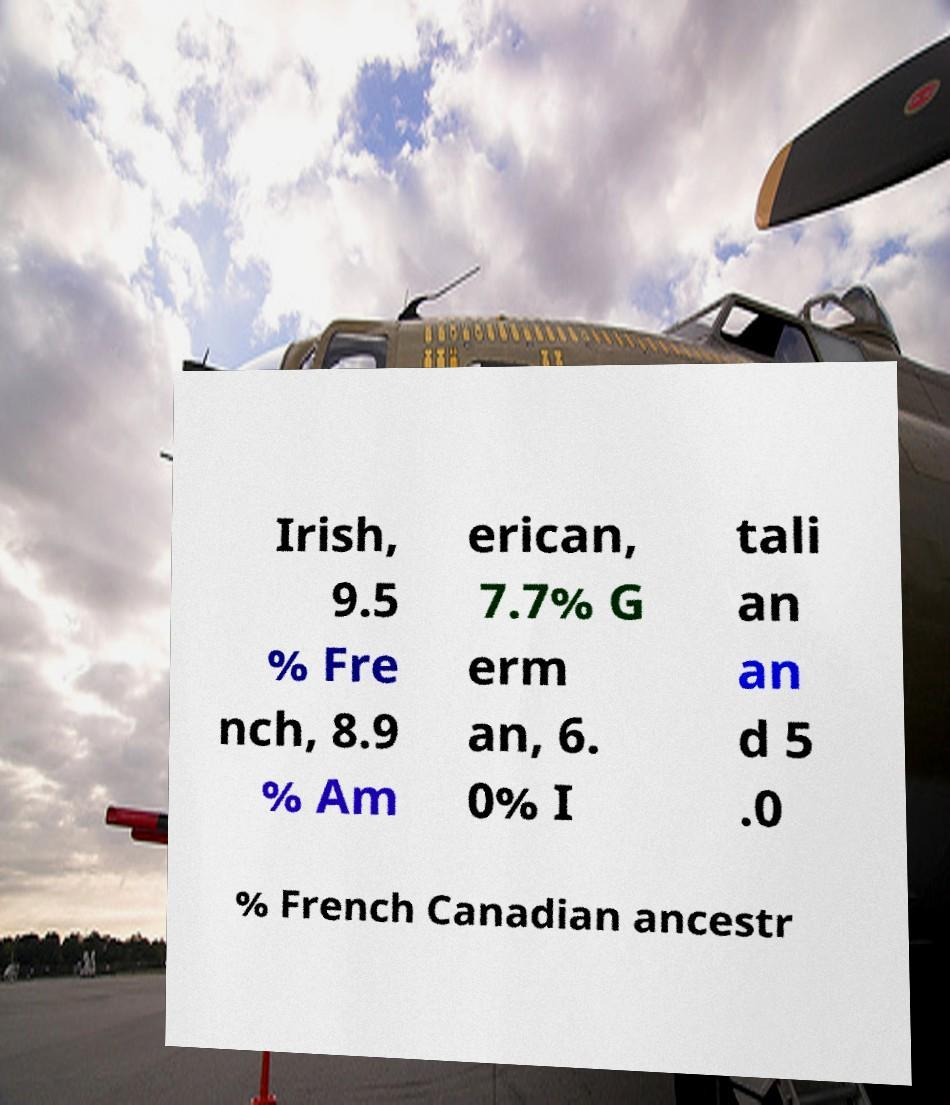For documentation purposes, I need the text within this image transcribed. Could you provide that? Irish, 9.5 % Fre nch, 8.9 % Am erican, 7.7% G erm an, 6. 0% I tali an an d 5 .0 % French Canadian ancestr 